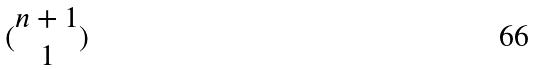Convert formula to latex. <formula><loc_0><loc_0><loc_500><loc_500>( \begin{matrix} n + 1 \\ 1 \end{matrix} )</formula> 